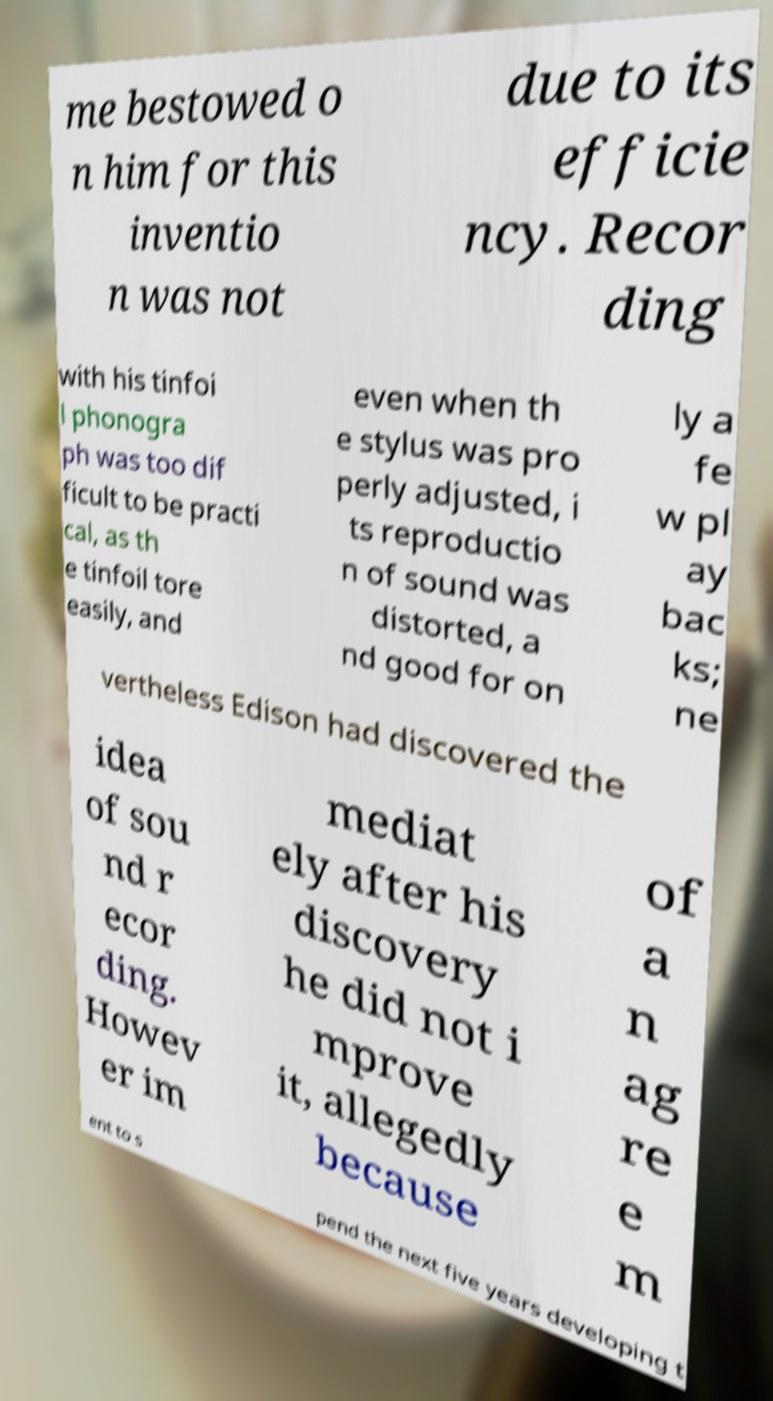I need the written content from this picture converted into text. Can you do that? me bestowed o n him for this inventio n was not due to its efficie ncy. Recor ding with his tinfoi l phonogra ph was too dif ficult to be practi cal, as th e tinfoil tore easily, and even when th e stylus was pro perly adjusted, i ts reproductio n of sound was distorted, a nd good for on ly a fe w pl ay bac ks; ne vertheless Edison had discovered the idea of sou nd r ecor ding. Howev er im mediat ely after his discovery he did not i mprove it, allegedly because of a n ag re e m ent to s pend the next five years developing t 